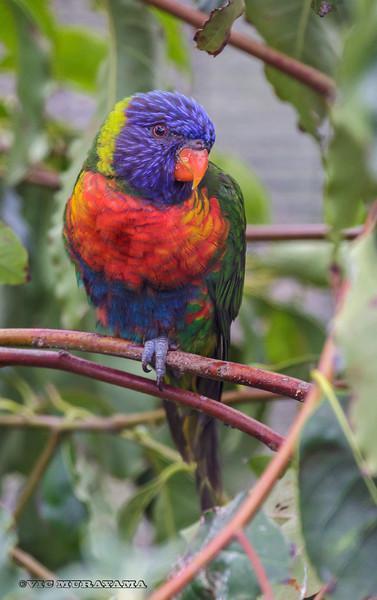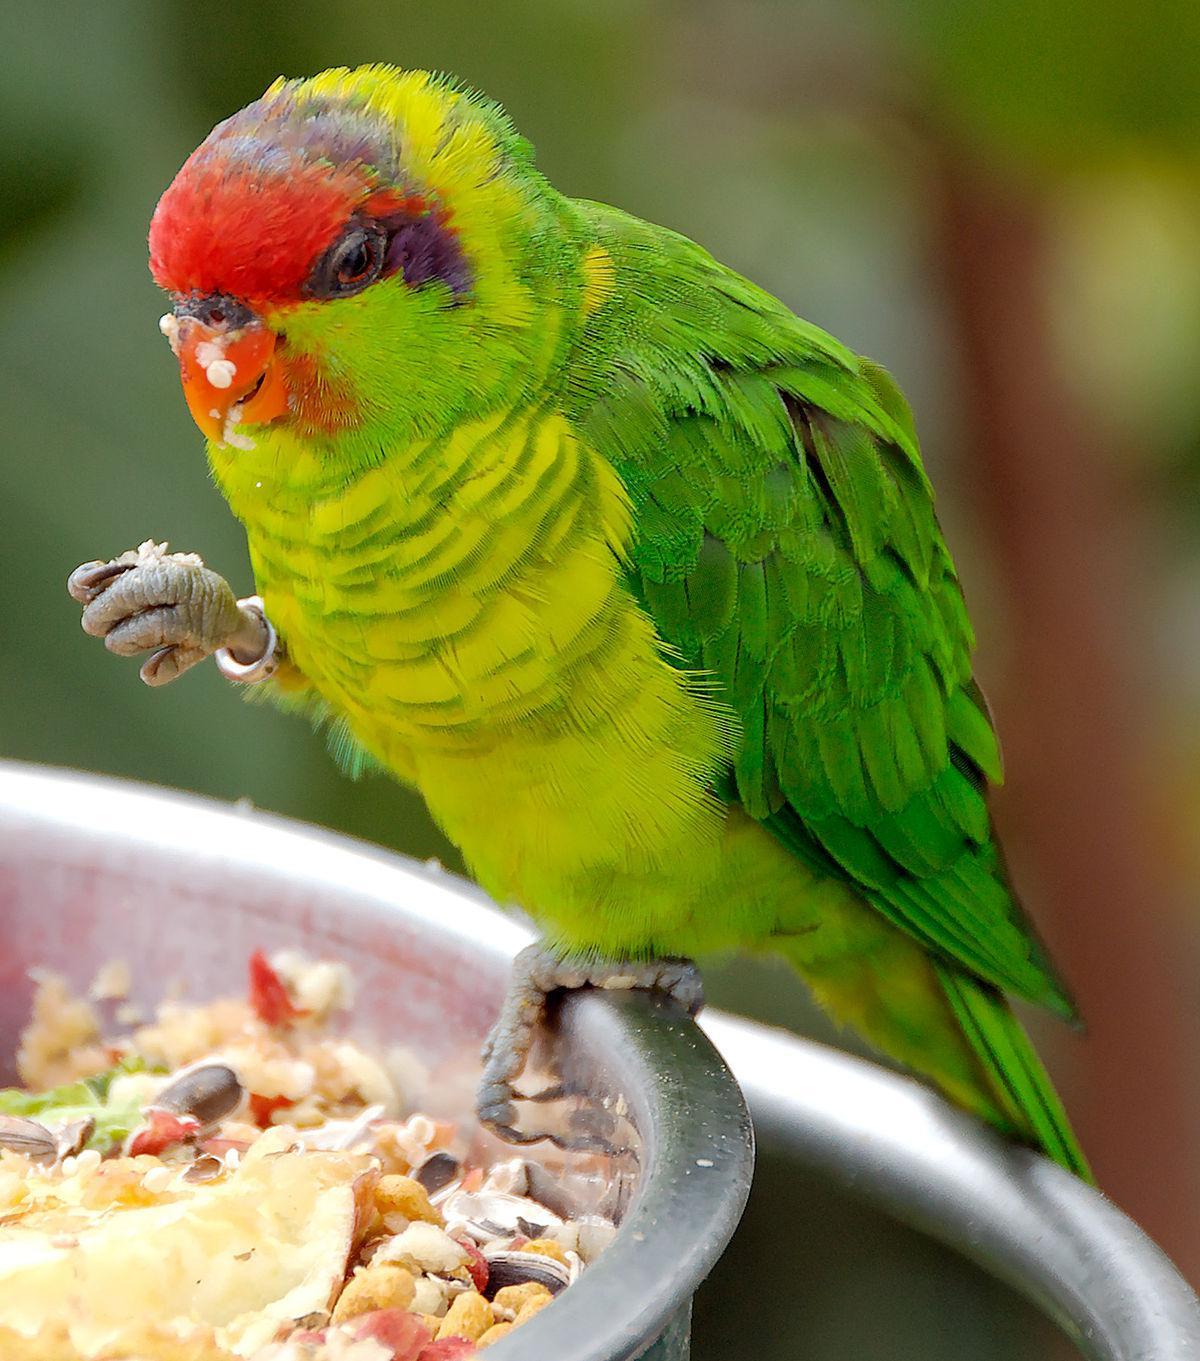The first image is the image on the left, the second image is the image on the right. Evaluate the accuracy of this statement regarding the images: "All of the images contain only one parrot.". Is it true? Answer yes or no. Yes. 